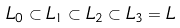<formula> <loc_0><loc_0><loc_500><loc_500>L _ { 0 } \subset L _ { 1 } \subset L _ { 2 } \subset L _ { 3 } = L</formula> 